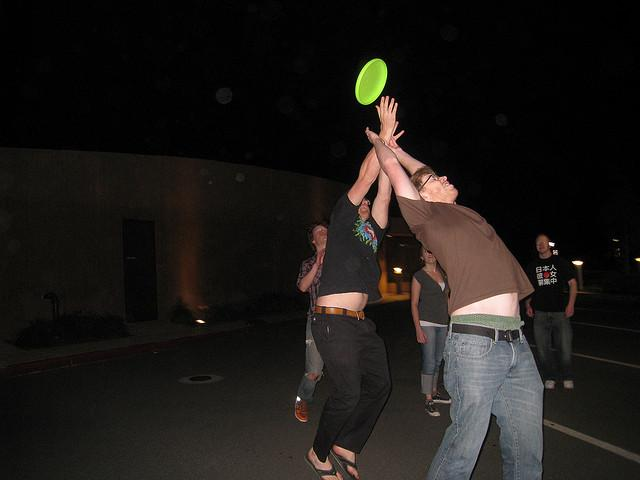WHat language is on the black shirt?

Choices:
A) chinese
B) english
C) french
D) italian chinese 